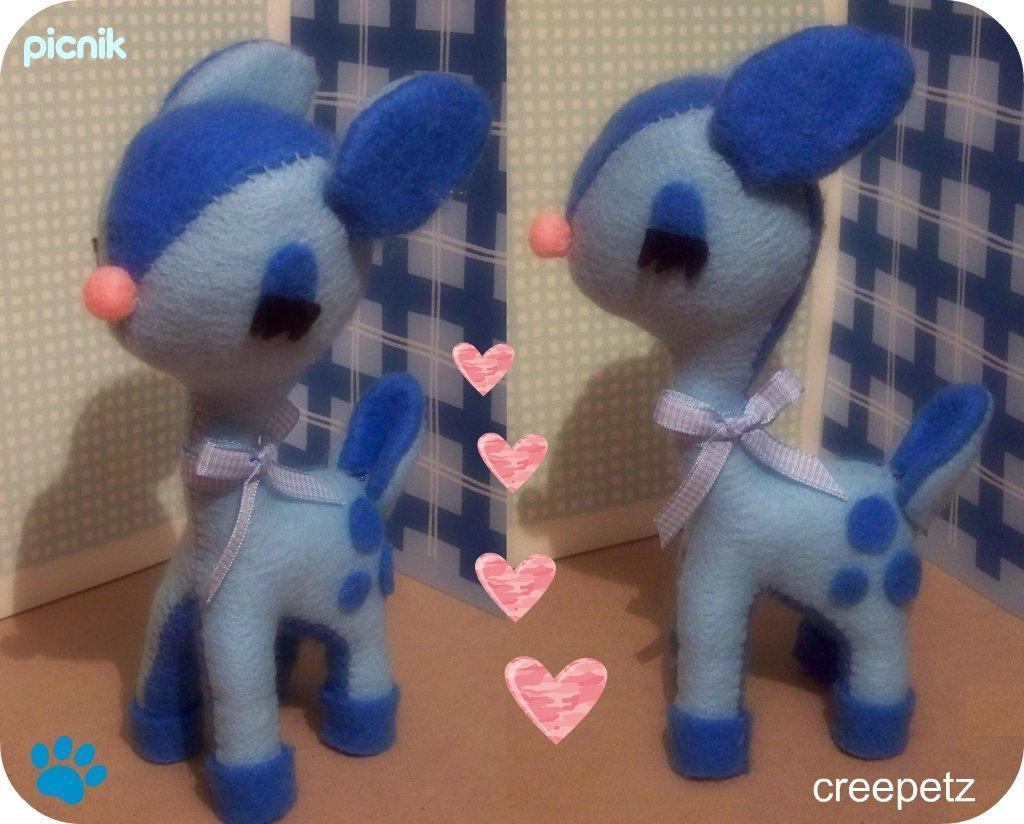Can you describe this image briefly? This is a collage image of two pictures where there is a toy, a few symbols, the wall and some text on the image. 